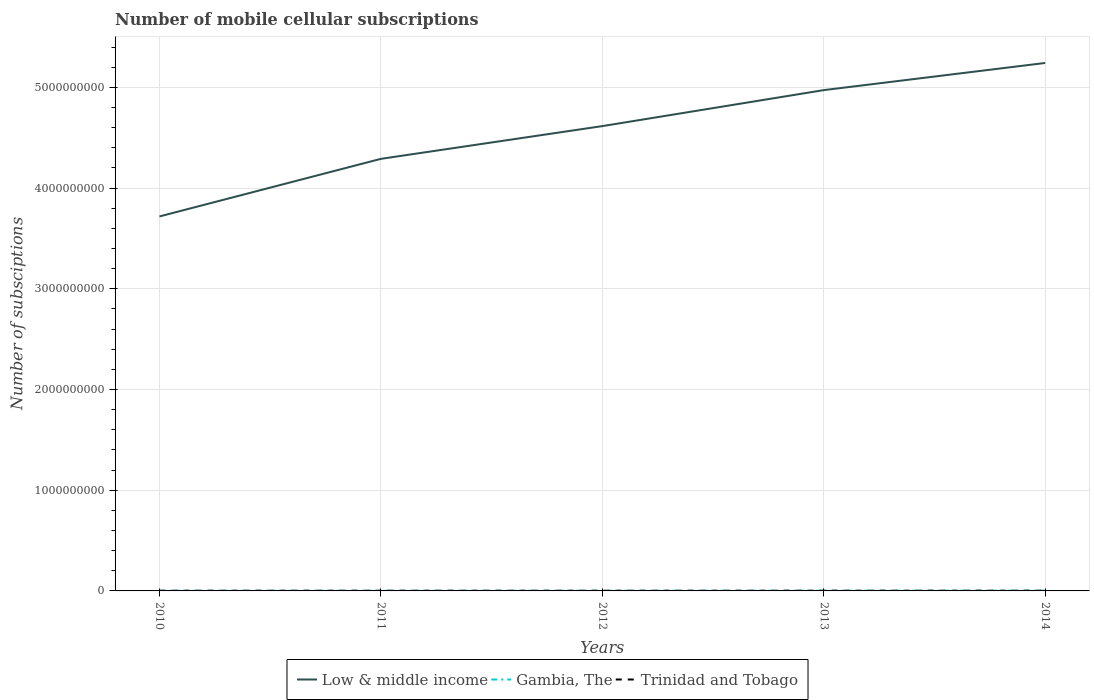How many different coloured lines are there?
Offer a very short reply. 3. Across all years, what is the maximum number of mobile cellular subscriptions in Low & middle income?
Keep it short and to the point. 3.72e+09. What is the total number of mobile cellular subscriptions in Low & middle income in the graph?
Your answer should be very brief. -6.27e+08. What is the difference between the highest and the second highest number of mobile cellular subscriptions in Gambia, The?
Provide a succinct answer. 8.83e+05. Is the number of mobile cellular subscriptions in Gambia, The strictly greater than the number of mobile cellular subscriptions in Trinidad and Tobago over the years?
Your answer should be compact. No. How many lines are there?
Ensure brevity in your answer.  3. How many years are there in the graph?
Keep it short and to the point. 5. Does the graph contain any zero values?
Ensure brevity in your answer.  No. Where does the legend appear in the graph?
Your response must be concise. Bottom center. How many legend labels are there?
Provide a succinct answer. 3. What is the title of the graph?
Your answer should be very brief. Number of mobile cellular subscriptions. Does "Equatorial Guinea" appear as one of the legend labels in the graph?
Make the answer very short. No. What is the label or title of the Y-axis?
Your response must be concise. Number of subsciptions. What is the Number of subsciptions of Low & middle income in 2010?
Offer a very short reply. 3.72e+09. What is the Number of subsciptions of Gambia, The in 2010?
Provide a succinct answer. 1.48e+06. What is the Number of subsciptions of Trinidad and Tobago in 2010?
Make the answer very short. 1.89e+06. What is the Number of subsciptions of Low & middle income in 2011?
Give a very brief answer. 4.29e+09. What is the Number of subsciptions of Gambia, The in 2011?
Offer a terse response. 1.40e+06. What is the Number of subsciptions of Trinidad and Tobago in 2011?
Give a very brief answer. 1.83e+06. What is the Number of subsciptions of Low & middle income in 2012?
Provide a short and direct response. 4.62e+09. What is the Number of subsciptions in Gambia, The in 2012?
Make the answer very short. 1.53e+06. What is the Number of subsciptions of Trinidad and Tobago in 2012?
Keep it short and to the point. 1.88e+06. What is the Number of subsciptions in Low & middle income in 2013?
Your response must be concise. 4.97e+09. What is the Number of subsciptions of Gambia, The in 2013?
Offer a very short reply. 1.85e+06. What is the Number of subsciptions in Trinidad and Tobago in 2013?
Give a very brief answer. 1.94e+06. What is the Number of subsciptions of Low & middle income in 2014?
Provide a short and direct response. 5.24e+09. What is the Number of subsciptions of Gambia, The in 2014?
Make the answer very short. 2.28e+06. What is the Number of subsciptions of Trinidad and Tobago in 2014?
Make the answer very short. 1.98e+06. Across all years, what is the maximum Number of subsciptions in Low & middle income?
Ensure brevity in your answer.  5.24e+09. Across all years, what is the maximum Number of subsciptions of Gambia, The?
Ensure brevity in your answer.  2.28e+06. Across all years, what is the maximum Number of subsciptions in Trinidad and Tobago?
Ensure brevity in your answer.  1.98e+06. Across all years, what is the minimum Number of subsciptions in Low & middle income?
Offer a very short reply. 3.72e+09. Across all years, what is the minimum Number of subsciptions of Gambia, The?
Ensure brevity in your answer.  1.40e+06. Across all years, what is the minimum Number of subsciptions of Trinidad and Tobago?
Make the answer very short. 1.83e+06. What is the total Number of subsciptions of Low & middle income in the graph?
Offer a terse response. 2.28e+1. What is the total Number of subsciptions in Gambia, The in the graph?
Your answer should be very brief. 8.54e+06. What is the total Number of subsciptions of Trinidad and Tobago in the graph?
Offer a terse response. 9.53e+06. What is the difference between the Number of subsciptions in Low & middle income in 2010 and that in 2011?
Offer a terse response. -5.72e+08. What is the difference between the Number of subsciptions in Gambia, The in 2010 and that in 2011?
Provide a succinct answer. 7.72e+04. What is the difference between the Number of subsciptions in Trinidad and Tobago in 2010 and that in 2011?
Your response must be concise. 6.80e+04. What is the difference between the Number of subsciptions of Low & middle income in 2010 and that in 2012?
Your answer should be very brief. -8.97e+08. What is the difference between the Number of subsciptions in Gambia, The in 2010 and that in 2012?
Your answer should be very brief. -4.78e+04. What is the difference between the Number of subsciptions in Trinidad and Tobago in 2010 and that in 2012?
Provide a succinct answer. 1.06e+04. What is the difference between the Number of subsciptions in Low & middle income in 2010 and that in 2013?
Keep it short and to the point. -1.25e+09. What is the difference between the Number of subsciptions in Gambia, The in 2010 and that in 2013?
Offer a terse response. -3.71e+05. What is the difference between the Number of subsciptions of Trinidad and Tobago in 2010 and that in 2013?
Your answer should be compact. -4.96e+04. What is the difference between the Number of subsciptions in Low & middle income in 2010 and that in 2014?
Your response must be concise. -1.52e+09. What is the difference between the Number of subsciptions in Gambia, The in 2010 and that in 2014?
Provide a succinct answer. -8.05e+05. What is the difference between the Number of subsciptions of Trinidad and Tobago in 2010 and that in 2014?
Offer a terse response. -8.63e+04. What is the difference between the Number of subsciptions in Low & middle income in 2011 and that in 2012?
Ensure brevity in your answer.  -3.25e+08. What is the difference between the Number of subsciptions of Gambia, The in 2011 and that in 2012?
Your answer should be compact. -1.25e+05. What is the difference between the Number of subsciptions in Trinidad and Tobago in 2011 and that in 2012?
Your response must be concise. -5.75e+04. What is the difference between the Number of subsciptions of Low & middle income in 2011 and that in 2013?
Keep it short and to the point. -6.82e+08. What is the difference between the Number of subsciptions of Gambia, The in 2011 and that in 2013?
Your answer should be very brief. -4.48e+05. What is the difference between the Number of subsciptions of Trinidad and Tobago in 2011 and that in 2013?
Keep it short and to the point. -1.18e+05. What is the difference between the Number of subsciptions of Low & middle income in 2011 and that in 2014?
Keep it short and to the point. -9.52e+08. What is the difference between the Number of subsciptions of Gambia, The in 2011 and that in 2014?
Offer a terse response. -8.83e+05. What is the difference between the Number of subsciptions of Trinidad and Tobago in 2011 and that in 2014?
Make the answer very short. -1.54e+05. What is the difference between the Number of subsciptions of Low & middle income in 2012 and that in 2013?
Keep it short and to the point. -3.57e+08. What is the difference between the Number of subsciptions of Gambia, The in 2012 and that in 2013?
Your response must be concise. -3.23e+05. What is the difference between the Number of subsciptions of Trinidad and Tobago in 2012 and that in 2013?
Ensure brevity in your answer.  -6.02e+04. What is the difference between the Number of subsciptions of Low & middle income in 2012 and that in 2014?
Give a very brief answer. -6.27e+08. What is the difference between the Number of subsciptions in Gambia, The in 2012 and that in 2014?
Ensure brevity in your answer.  -7.58e+05. What is the difference between the Number of subsciptions of Trinidad and Tobago in 2012 and that in 2014?
Give a very brief answer. -9.69e+04. What is the difference between the Number of subsciptions in Low & middle income in 2013 and that in 2014?
Your answer should be compact. -2.70e+08. What is the difference between the Number of subsciptions in Gambia, The in 2013 and that in 2014?
Offer a terse response. -4.35e+05. What is the difference between the Number of subsciptions of Trinidad and Tobago in 2013 and that in 2014?
Offer a terse response. -3.67e+04. What is the difference between the Number of subsciptions of Low & middle income in 2010 and the Number of subsciptions of Gambia, The in 2011?
Offer a terse response. 3.72e+09. What is the difference between the Number of subsciptions in Low & middle income in 2010 and the Number of subsciptions in Trinidad and Tobago in 2011?
Make the answer very short. 3.72e+09. What is the difference between the Number of subsciptions in Gambia, The in 2010 and the Number of subsciptions in Trinidad and Tobago in 2011?
Keep it short and to the point. -3.48e+05. What is the difference between the Number of subsciptions in Low & middle income in 2010 and the Number of subsciptions in Gambia, The in 2012?
Your answer should be very brief. 3.72e+09. What is the difference between the Number of subsciptions in Low & middle income in 2010 and the Number of subsciptions in Trinidad and Tobago in 2012?
Ensure brevity in your answer.  3.72e+09. What is the difference between the Number of subsciptions of Gambia, The in 2010 and the Number of subsciptions of Trinidad and Tobago in 2012?
Offer a terse response. -4.05e+05. What is the difference between the Number of subsciptions in Low & middle income in 2010 and the Number of subsciptions in Gambia, The in 2013?
Provide a short and direct response. 3.72e+09. What is the difference between the Number of subsciptions in Low & middle income in 2010 and the Number of subsciptions in Trinidad and Tobago in 2013?
Your answer should be compact. 3.72e+09. What is the difference between the Number of subsciptions in Gambia, The in 2010 and the Number of subsciptions in Trinidad and Tobago in 2013?
Provide a succinct answer. -4.66e+05. What is the difference between the Number of subsciptions of Low & middle income in 2010 and the Number of subsciptions of Gambia, The in 2014?
Provide a short and direct response. 3.72e+09. What is the difference between the Number of subsciptions in Low & middle income in 2010 and the Number of subsciptions in Trinidad and Tobago in 2014?
Your answer should be very brief. 3.72e+09. What is the difference between the Number of subsciptions in Gambia, The in 2010 and the Number of subsciptions in Trinidad and Tobago in 2014?
Your answer should be compact. -5.02e+05. What is the difference between the Number of subsciptions in Low & middle income in 2011 and the Number of subsciptions in Gambia, The in 2012?
Offer a very short reply. 4.29e+09. What is the difference between the Number of subsciptions of Low & middle income in 2011 and the Number of subsciptions of Trinidad and Tobago in 2012?
Keep it short and to the point. 4.29e+09. What is the difference between the Number of subsciptions in Gambia, The in 2011 and the Number of subsciptions in Trinidad and Tobago in 2012?
Your response must be concise. -4.83e+05. What is the difference between the Number of subsciptions in Low & middle income in 2011 and the Number of subsciptions in Gambia, The in 2013?
Your answer should be compact. 4.29e+09. What is the difference between the Number of subsciptions of Low & middle income in 2011 and the Number of subsciptions of Trinidad and Tobago in 2013?
Offer a terse response. 4.29e+09. What is the difference between the Number of subsciptions of Gambia, The in 2011 and the Number of subsciptions of Trinidad and Tobago in 2013?
Make the answer very short. -5.43e+05. What is the difference between the Number of subsciptions in Low & middle income in 2011 and the Number of subsciptions in Gambia, The in 2014?
Make the answer very short. 4.29e+09. What is the difference between the Number of subsciptions in Low & middle income in 2011 and the Number of subsciptions in Trinidad and Tobago in 2014?
Provide a succinct answer. 4.29e+09. What is the difference between the Number of subsciptions in Gambia, The in 2011 and the Number of subsciptions in Trinidad and Tobago in 2014?
Offer a very short reply. -5.79e+05. What is the difference between the Number of subsciptions in Low & middle income in 2012 and the Number of subsciptions in Gambia, The in 2013?
Provide a succinct answer. 4.61e+09. What is the difference between the Number of subsciptions of Low & middle income in 2012 and the Number of subsciptions of Trinidad and Tobago in 2013?
Ensure brevity in your answer.  4.61e+09. What is the difference between the Number of subsciptions of Gambia, The in 2012 and the Number of subsciptions of Trinidad and Tobago in 2013?
Offer a terse response. -4.18e+05. What is the difference between the Number of subsciptions of Low & middle income in 2012 and the Number of subsciptions of Gambia, The in 2014?
Provide a short and direct response. 4.61e+09. What is the difference between the Number of subsciptions of Low & middle income in 2012 and the Number of subsciptions of Trinidad and Tobago in 2014?
Your answer should be very brief. 4.61e+09. What is the difference between the Number of subsciptions in Gambia, The in 2012 and the Number of subsciptions in Trinidad and Tobago in 2014?
Provide a short and direct response. -4.54e+05. What is the difference between the Number of subsciptions of Low & middle income in 2013 and the Number of subsciptions of Gambia, The in 2014?
Offer a terse response. 4.97e+09. What is the difference between the Number of subsciptions of Low & middle income in 2013 and the Number of subsciptions of Trinidad and Tobago in 2014?
Keep it short and to the point. 4.97e+09. What is the difference between the Number of subsciptions of Gambia, The in 2013 and the Number of subsciptions of Trinidad and Tobago in 2014?
Ensure brevity in your answer.  -1.32e+05. What is the average Number of subsciptions in Low & middle income per year?
Ensure brevity in your answer.  4.57e+09. What is the average Number of subsciptions of Gambia, The per year?
Provide a succinct answer. 1.71e+06. What is the average Number of subsciptions of Trinidad and Tobago per year?
Your answer should be compact. 1.91e+06. In the year 2010, what is the difference between the Number of subsciptions in Low & middle income and Number of subsciptions in Gambia, The?
Ensure brevity in your answer.  3.72e+09. In the year 2010, what is the difference between the Number of subsciptions of Low & middle income and Number of subsciptions of Trinidad and Tobago?
Make the answer very short. 3.72e+09. In the year 2010, what is the difference between the Number of subsciptions of Gambia, The and Number of subsciptions of Trinidad and Tobago?
Give a very brief answer. -4.16e+05. In the year 2011, what is the difference between the Number of subsciptions of Low & middle income and Number of subsciptions of Gambia, The?
Your answer should be compact. 4.29e+09. In the year 2011, what is the difference between the Number of subsciptions in Low & middle income and Number of subsciptions in Trinidad and Tobago?
Give a very brief answer. 4.29e+09. In the year 2011, what is the difference between the Number of subsciptions of Gambia, The and Number of subsciptions of Trinidad and Tobago?
Give a very brief answer. -4.25e+05. In the year 2012, what is the difference between the Number of subsciptions in Low & middle income and Number of subsciptions in Gambia, The?
Keep it short and to the point. 4.61e+09. In the year 2012, what is the difference between the Number of subsciptions of Low & middle income and Number of subsciptions of Trinidad and Tobago?
Provide a short and direct response. 4.61e+09. In the year 2012, what is the difference between the Number of subsciptions of Gambia, The and Number of subsciptions of Trinidad and Tobago?
Keep it short and to the point. -3.57e+05. In the year 2013, what is the difference between the Number of subsciptions of Low & middle income and Number of subsciptions of Gambia, The?
Provide a succinct answer. 4.97e+09. In the year 2013, what is the difference between the Number of subsciptions in Low & middle income and Number of subsciptions in Trinidad and Tobago?
Make the answer very short. 4.97e+09. In the year 2013, what is the difference between the Number of subsciptions of Gambia, The and Number of subsciptions of Trinidad and Tobago?
Give a very brief answer. -9.50e+04. In the year 2014, what is the difference between the Number of subsciptions of Low & middle income and Number of subsciptions of Gambia, The?
Provide a short and direct response. 5.24e+09. In the year 2014, what is the difference between the Number of subsciptions of Low & middle income and Number of subsciptions of Trinidad and Tobago?
Give a very brief answer. 5.24e+09. In the year 2014, what is the difference between the Number of subsciptions of Gambia, The and Number of subsciptions of Trinidad and Tobago?
Your answer should be very brief. 3.03e+05. What is the ratio of the Number of subsciptions of Low & middle income in 2010 to that in 2011?
Offer a very short reply. 0.87. What is the ratio of the Number of subsciptions of Gambia, The in 2010 to that in 2011?
Ensure brevity in your answer.  1.06. What is the ratio of the Number of subsciptions of Trinidad and Tobago in 2010 to that in 2011?
Ensure brevity in your answer.  1.04. What is the ratio of the Number of subsciptions in Low & middle income in 2010 to that in 2012?
Give a very brief answer. 0.81. What is the ratio of the Number of subsciptions of Gambia, The in 2010 to that in 2012?
Make the answer very short. 0.97. What is the ratio of the Number of subsciptions in Trinidad and Tobago in 2010 to that in 2012?
Provide a short and direct response. 1.01. What is the ratio of the Number of subsciptions of Low & middle income in 2010 to that in 2013?
Your answer should be compact. 0.75. What is the ratio of the Number of subsciptions of Gambia, The in 2010 to that in 2013?
Ensure brevity in your answer.  0.8. What is the ratio of the Number of subsciptions in Trinidad and Tobago in 2010 to that in 2013?
Provide a succinct answer. 0.97. What is the ratio of the Number of subsciptions of Low & middle income in 2010 to that in 2014?
Provide a short and direct response. 0.71. What is the ratio of the Number of subsciptions of Gambia, The in 2010 to that in 2014?
Make the answer very short. 0.65. What is the ratio of the Number of subsciptions of Trinidad and Tobago in 2010 to that in 2014?
Give a very brief answer. 0.96. What is the ratio of the Number of subsciptions of Low & middle income in 2011 to that in 2012?
Offer a very short reply. 0.93. What is the ratio of the Number of subsciptions of Gambia, The in 2011 to that in 2012?
Keep it short and to the point. 0.92. What is the ratio of the Number of subsciptions in Trinidad and Tobago in 2011 to that in 2012?
Make the answer very short. 0.97. What is the ratio of the Number of subsciptions in Low & middle income in 2011 to that in 2013?
Your answer should be very brief. 0.86. What is the ratio of the Number of subsciptions of Gambia, The in 2011 to that in 2013?
Your answer should be very brief. 0.76. What is the ratio of the Number of subsciptions of Trinidad and Tobago in 2011 to that in 2013?
Provide a short and direct response. 0.94. What is the ratio of the Number of subsciptions in Low & middle income in 2011 to that in 2014?
Keep it short and to the point. 0.82. What is the ratio of the Number of subsciptions of Gambia, The in 2011 to that in 2014?
Give a very brief answer. 0.61. What is the ratio of the Number of subsciptions of Trinidad and Tobago in 2011 to that in 2014?
Your answer should be very brief. 0.92. What is the ratio of the Number of subsciptions of Low & middle income in 2012 to that in 2013?
Give a very brief answer. 0.93. What is the ratio of the Number of subsciptions in Gambia, The in 2012 to that in 2013?
Provide a short and direct response. 0.83. What is the ratio of the Number of subsciptions in Low & middle income in 2012 to that in 2014?
Your answer should be compact. 0.88. What is the ratio of the Number of subsciptions in Gambia, The in 2012 to that in 2014?
Keep it short and to the point. 0.67. What is the ratio of the Number of subsciptions of Trinidad and Tobago in 2012 to that in 2014?
Give a very brief answer. 0.95. What is the ratio of the Number of subsciptions of Low & middle income in 2013 to that in 2014?
Offer a terse response. 0.95. What is the ratio of the Number of subsciptions of Gambia, The in 2013 to that in 2014?
Your answer should be very brief. 0.81. What is the ratio of the Number of subsciptions in Trinidad and Tobago in 2013 to that in 2014?
Your response must be concise. 0.98. What is the difference between the highest and the second highest Number of subsciptions of Low & middle income?
Ensure brevity in your answer.  2.70e+08. What is the difference between the highest and the second highest Number of subsciptions in Gambia, The?
Give a very brief answer. 4.35e+05. What is the difference between the highest and the second highest Number of subsciptions in Trinidad and Tobago?
Your answer should be compact. 3.67e+04. What is the difference between the highest and the lowest Number of subsciptions in Low & middle income?
Ensure brevity in your answer.  1.52e+09. What is the difference between the highest and the lowest Number of subsciptions in Gambia, The?
Your answer should be compact. 8.83e+05. What is the difference between the highest and the lowest Number of subsciptions of Trinidad and Tobago?
Your answer should be very brief. 1.54e+05. 